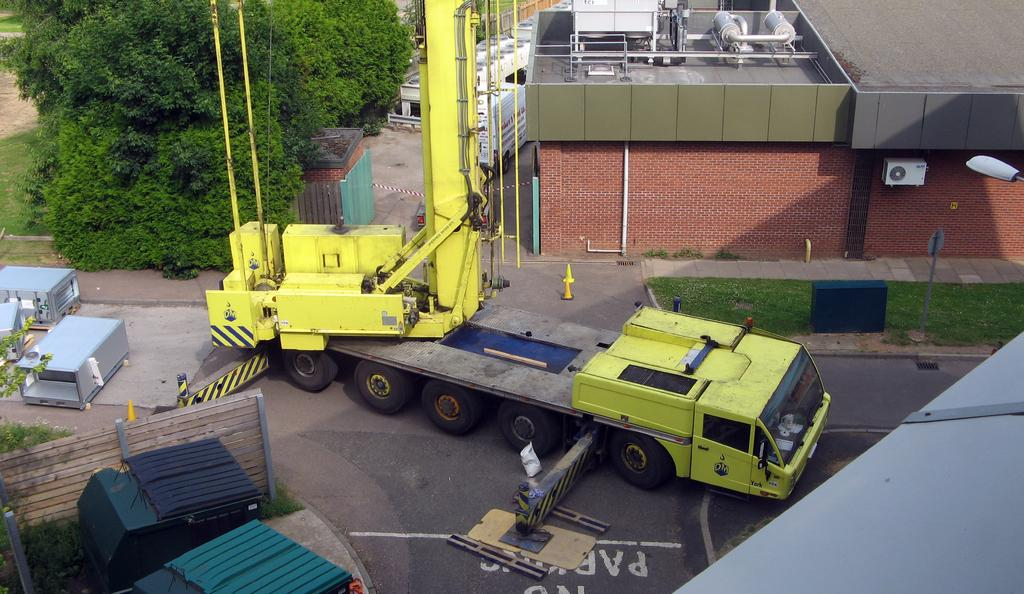What is on the road in the image? There is a vehicle on the road in the image. What objects can be seen near the road? Iron rods, boxes, and a fence are present near the road in the image. What type of lighting is available in the image? There is a street light in the image. What type of vegetation is visible in the image? Trees and grass are visible in the image. What type of structures are present in the image? There are buildings in the image. What type of rose can be seen growing on the vehicle in the image? There are no roses present in the image, let alone growing on the vehicle. 